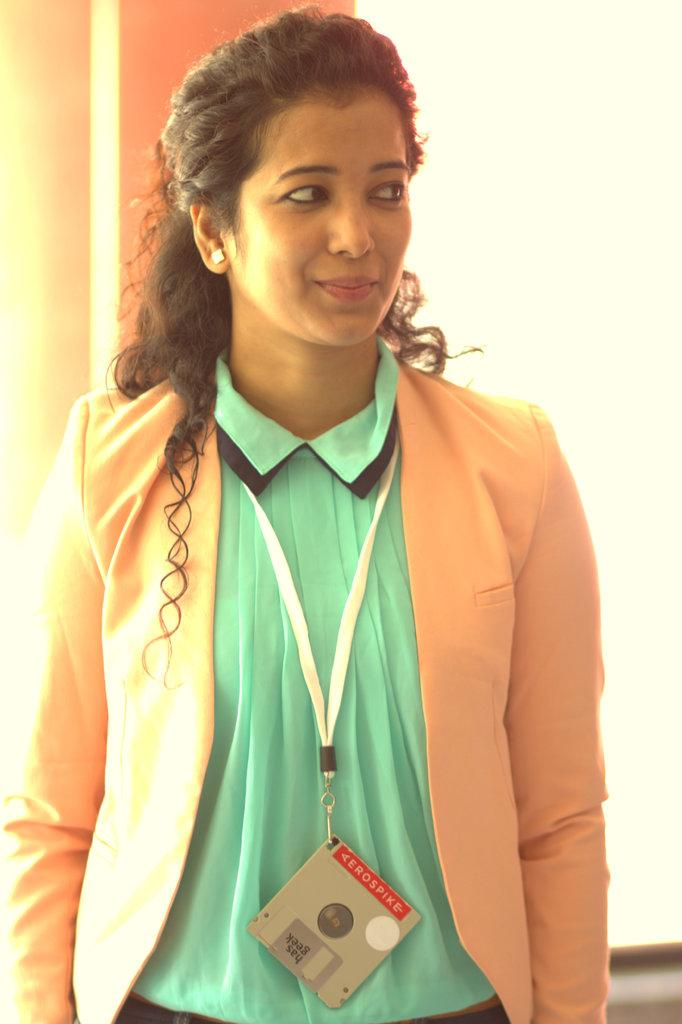What is the color of the wall in the image? There is a white color wall in the image. What can be seen in front of the wall? There is a woman standing in the image. What is the woman wearing on her upper body? The woman is wearing an orange color jacket. What is the woman wearing on her lower body? The woman is wearing a green color dress. Where is the sink located in the image? There is no sink present in the image. What type of meal is being prepared in the image? There is no meal preparation visible in the image. 